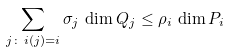<formula> <loc_0><loc_0><loc_500><loc_500>\sum _ { j \colon \, i ( j ) = i } \sigma _ { j } \, \dim Q _ { j } \leq \rho _ { i } \, \dim P _ { i }</formula> 